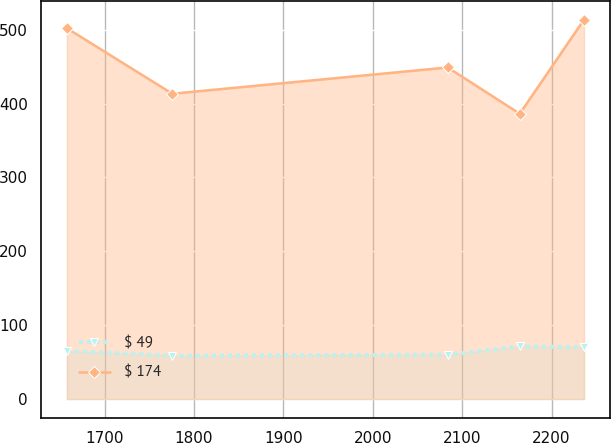Convert chart to OTSL. <chart><loc_0><loc_0><loc_500><loc_500><line_chart><ecel><fcel>$ 49<fcel>$ 174<nl><fcel>1657.92<fcel>65.19<fcel>502.02<nl><fcel>1775.84<fcel>58.8<fcel>413.32<nl><fcel>2083.87<fcel>59.95<fcel>448.89<nl><fcel>2164.45<fcel>71.36<fcel>386.27<nl><fcel>2236.37<fcel>70.21<fcel>513.76<nl></chart> 